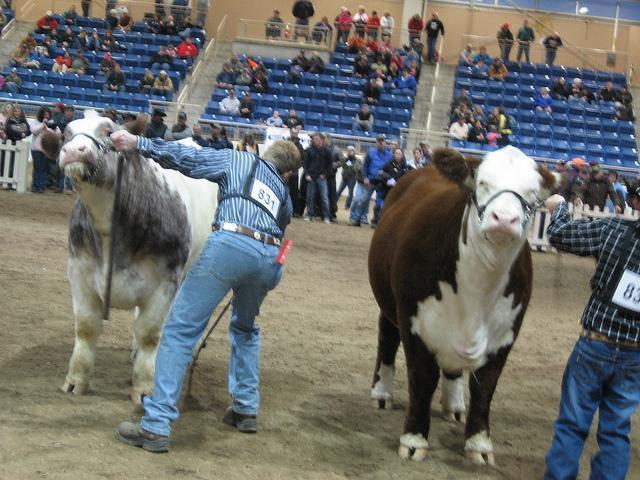How many people are there?
Give a very brief answer. 3. How many cows are in the photo?
Give a very brief answer. 2. How many light colored trucks are there?
Give a very brief answer. 0. 